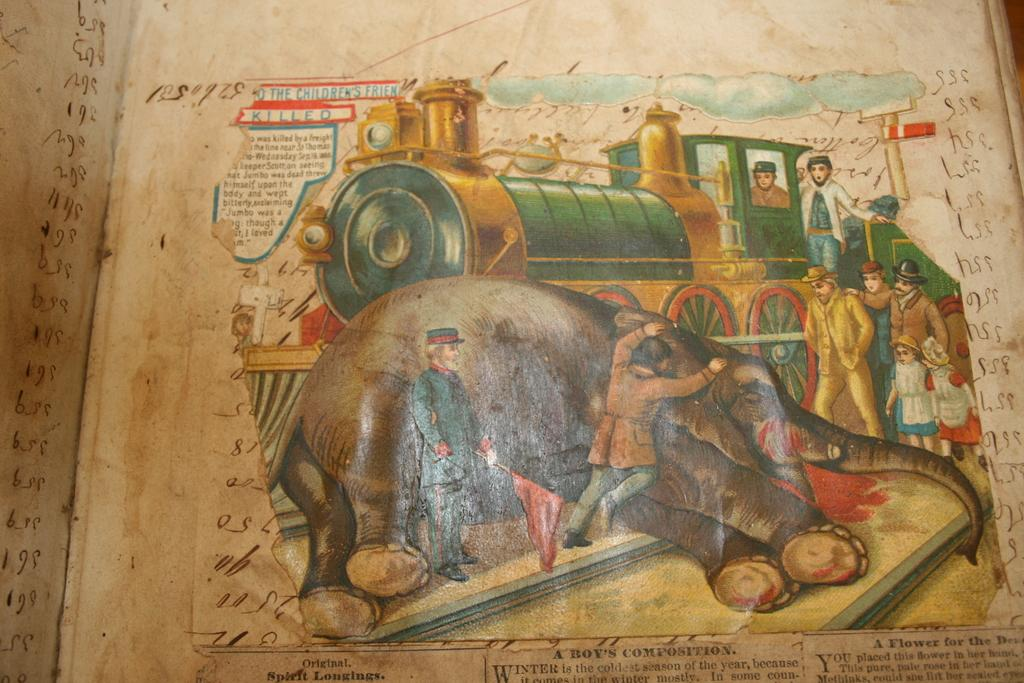<image>
Provide a brief description of the given image. a book with a train on it that says killed at the top 